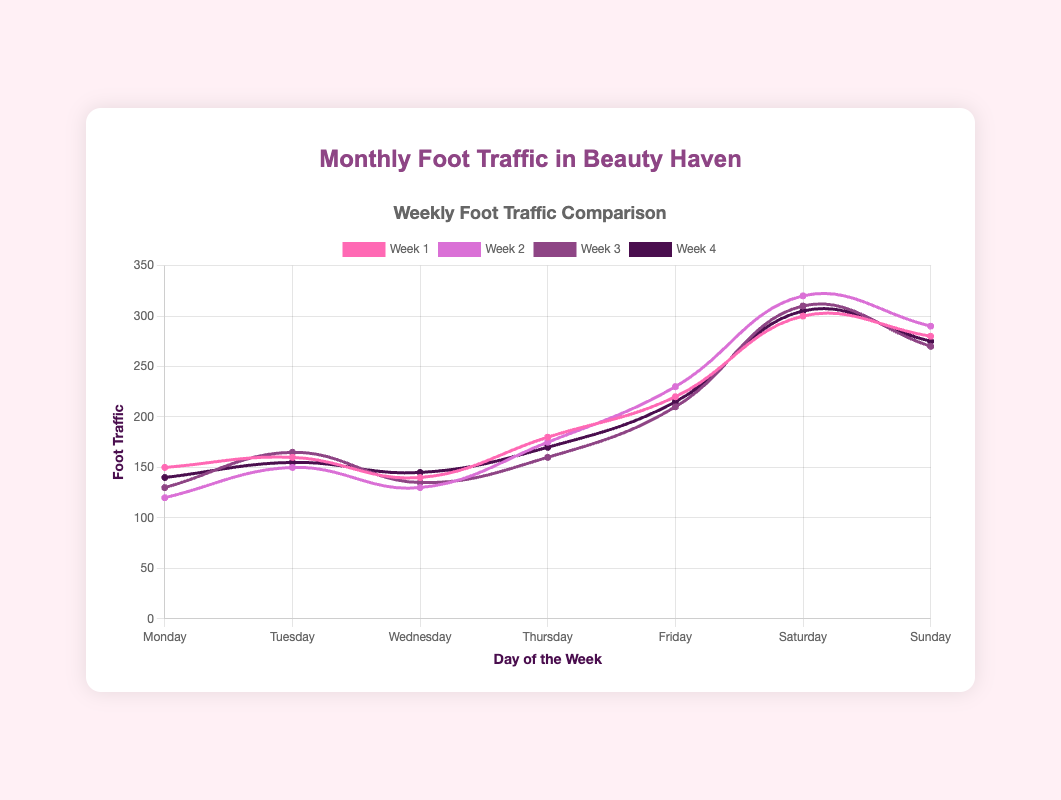What day has the highest foot traffic in week 2? To find this, look at the foot traffic values for each day in week 2. The values are Monday: 120, Tuesday: 150, Wednesday: 130, Thursday: 175, Friday: 230, Saturday: 320, Sunday: 290. Saturday has the highest foot traffic of 320.
Answer: Saturday What's the average foot traffic on Mondays? There are 4 data points for Mondays: 150, 120, 130, and 140. Add these values and divide by 4: (150 + 120 + 130 + 140)/4 = 540/4 = 135. So, the average foot traffic on Mondays is 135.
Answer: 135 Which day shows the biggest increase in foot traffic from week 1 to week 2? Compare the difference in foot traffic from week 1 to week 2 for each day: Monday: 120 - 150 = -30, Tuesday: 150 - 160 = -10, Wednesday: 130 - 140 = -10, Thursday: 175 - 180 = -5, Friday: 230 - 220 = 10, Saturday: 320 - 300 = 20, Sunday: 290 - 280 = 10. The biggest increase is on Saturday with an increase of 20.
Answer: Saturday Which day has the lowest average foot traffic over the four weeks? Calculate the average foot traffic for each day by adding their four-week values and dividing by 4. The averages are: Monday: 135, Tuesday: 157.5, Wednesday: 137.5, Thursday: 171.25, Friday: 218.75, Saturday: 308.75, Sunday: 278.75. Wednesday has the lowest average of 137.5.
Answer: Wednesday What is the total foot traffic on weekends (Saturday and Sunday) over the four weeks? Add the foot traffic values for every Saturday and Sunday over the four weeks: (300 + 320 + 310 + 305) + (280 + 290 + 270 + 275) = 1235 + 1115 = 2350.
Answer: 2350 Which day has the most consistent foot traffic over the four weeks? Consistency can be measured by the smallest range (difference between the highest and lowest values) in foot traffic. Calculate the range for each day: Monday (150-120=30), Tuesday (165-150=15), Wednesday (145-130=15), Thursday (180-160=20), Friday (230-210=20), Saturday (320-300=20), Sunday (290-270=20). Tuesday and Wednesday both have the smallest range of 15, so they are the most consistent.
Answer: Tuesday and Wednesday Which week shows the highest overall foot traffic across all days? Sum the foot traffic for all days in each week: Week 1: 150+160+140+180+220+300+280 = 1430, Week 2: 120+150+130+175+230+320+290 = 1415, Week 3: 130+165+135+160+210+310+270 = 1380, Week 4: 140+155+145+170+215+305+275 = 1405. Week 1 has the highest overall foot traffic of 1430.
Answer: Week 1 How much more foot traffic is there on average on weekends compared to weekdays? Calculate the average foot traffic for weekends (Saturday and Sunday) and weekdays (Monday to Friday) over four weeks. Weekends: (300+320+310+305+280+290+270+275)/8 = 1175/8 = 293.75. Weekdays: (150+120+130+140+160+150+165+155+140+130+135+145+180+175+160+170+220+230+210+215)/20 = 3185/20 = 159.25. The difference is 293.75 - 159.25 = 134.5.
Answer: 134.5 